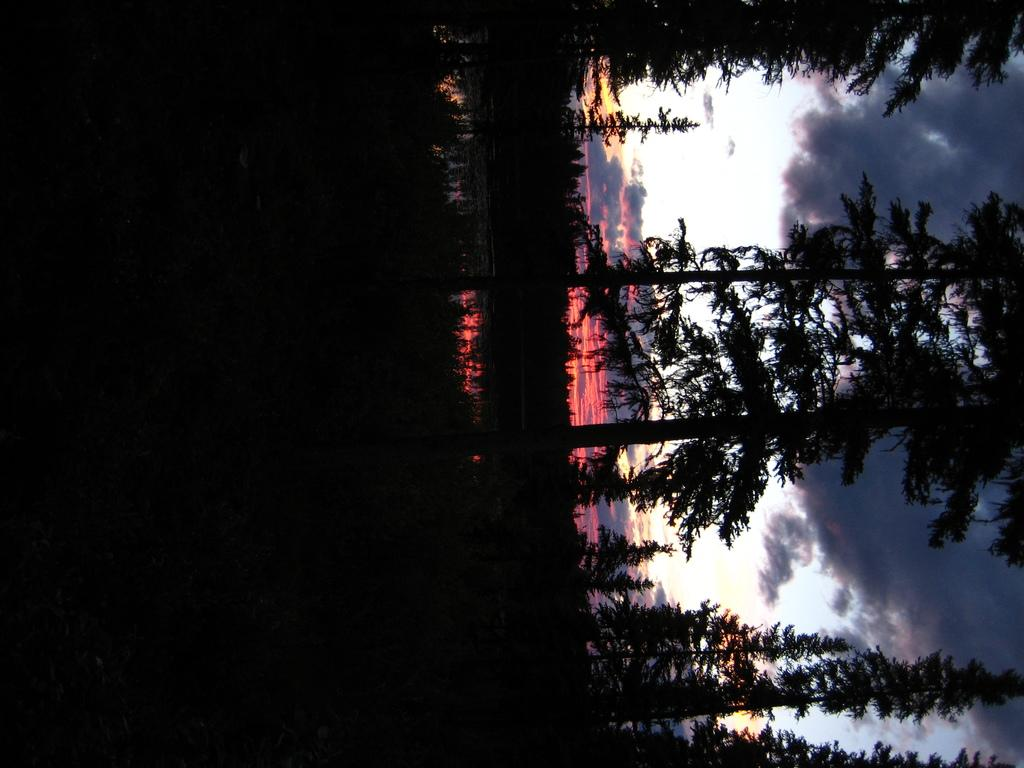What type of vegetation is present on the right side of the image? There are many trees on the right side of the image. What is the condition of the sky in the image? The sky is cloudy in the image. Where is the maid standing with her mitten in the image? There is no maid or mitten present in the image. What type of alley can be seen in the image? There is no alley present in the image. 